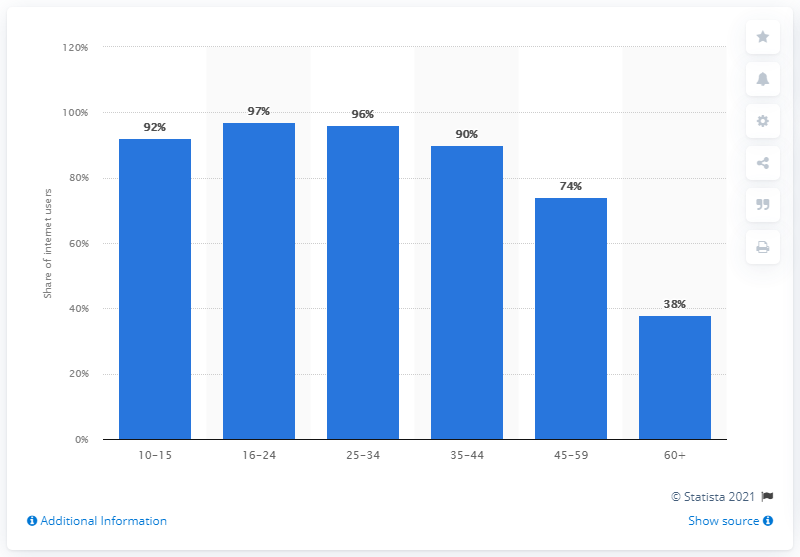Point out several critical features in this image. Of the respondents between the ages of 16 and 24, 97% had accessed the internet. According to the data, the internet penetration rate among Brazilians aged 60 and over was 38%. 